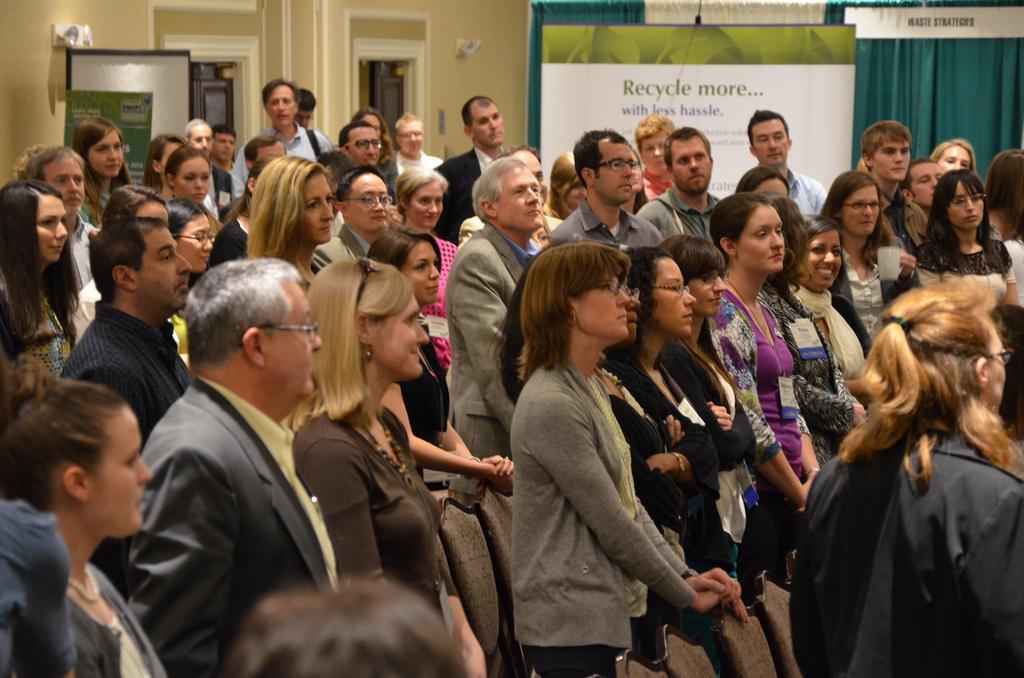In one or two sentences, can you explain what this image depicts? many people standing, there are banners, curtains and doorways at the back. 